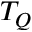Convert formula to latex. <formula><loc_0><loc_0><loc_500><loc_500>T _ { Q }</formula> 